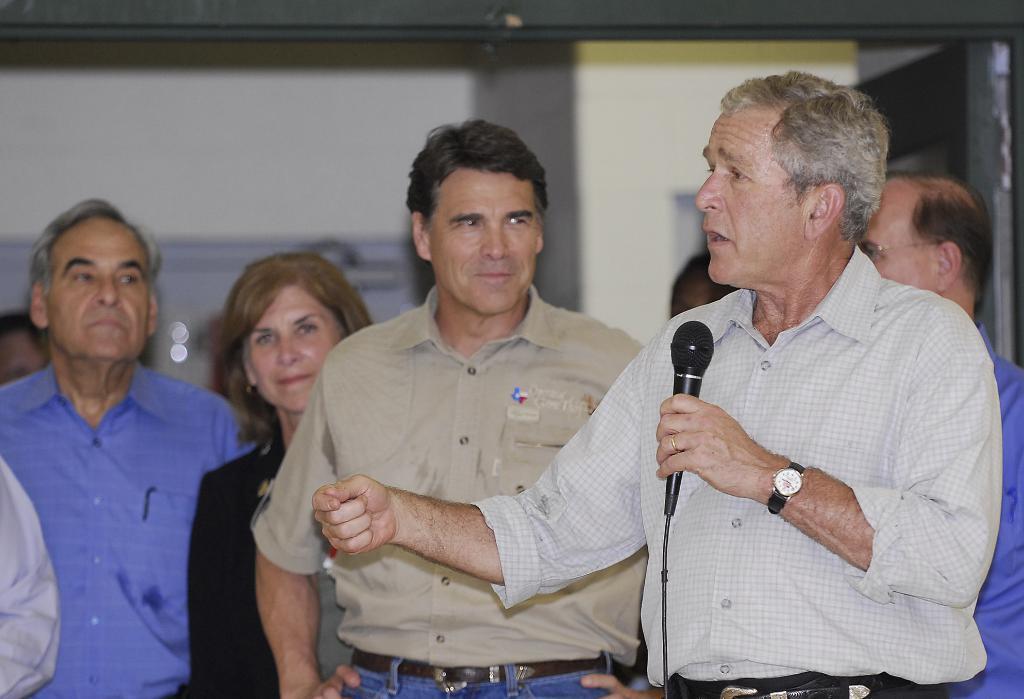Can you describe this image briefly? On the background we can see a wall. Here we can see one man standing and holding a mike in his hand and talking. He wore watch. On the background we can see few persons standing , holding a smile on their faces. 